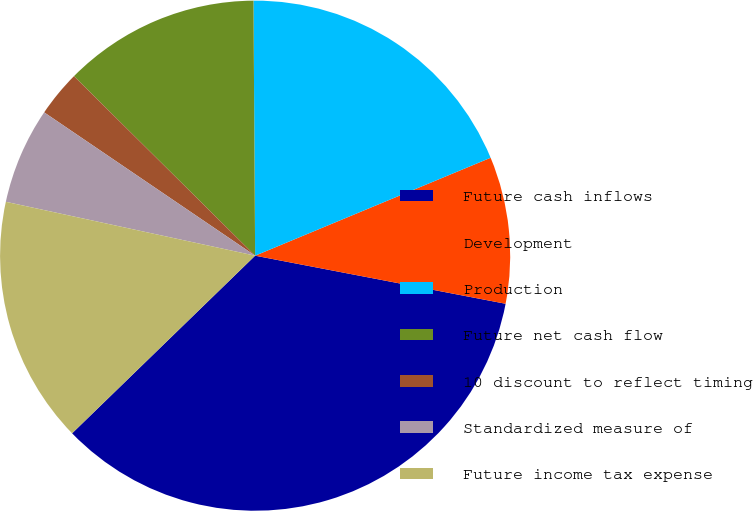Convert chart. <chart><loc_0><loc_0><loc_500><loc_500><pie_chart><fcel>Future cash inflows<fcel>Development<fcel>Production<fcel>Future net cash flow<fcel>10 discount to reflect timing<fcel>Standardized measure of<fcel>Future income tax expense<nl><fcel>34.72%<fcel>9.29%<fcel>18.83%<fcel>12.47%<fcel>2.93%<fcel>6.11%<fcel>15.65%<nl></chart> 